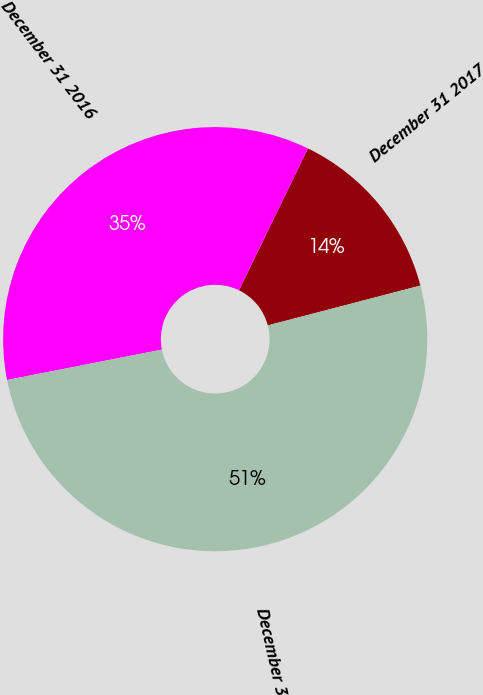<chart> <loc_0><loc_0><loc_500><loc_500><pie_chart><fcel>December 31 2017<fcel>December 31 2016<fcel>December 31 2015<nl><fcel>13.73%<fcel>35.29%<fcel>50.98%<nl></chart> 